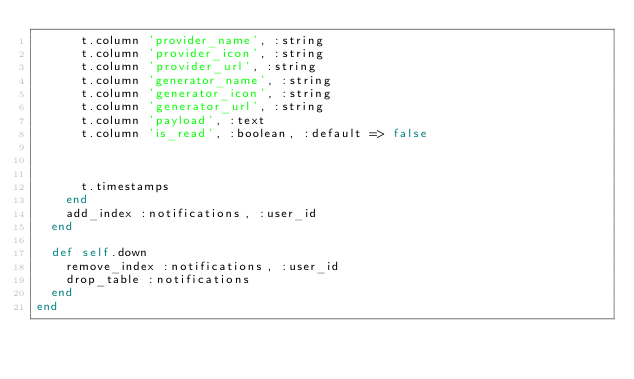Convert code to text. <code><loc_0><loc_0><loc_500><loc_500><_Ruby_>      t.column 'provider_name', :string
      t.column 'provider_icon', :string
      t.column 'provider_url', :string
      t.column 'generator_name', :string
      t.column 'generator_icon', :string
      t.column 'generator_url', :string
      t.column 'payload', :text
      t.column 'is_read', :boolean, :default => false
      
      

      t.timestamps
    end
    add_index :notifications, :user_id
  end

  def self.down
    remove_index :notifications, :user_id
    drop_table :notifications
  end
end</code> 